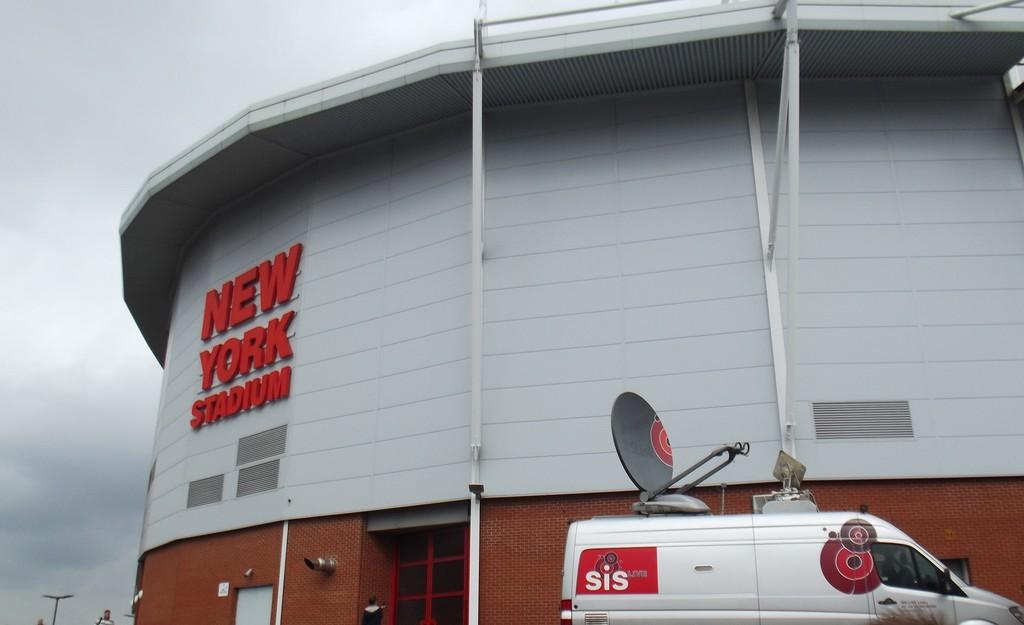<image>
Summarize the visual content of the image. a truck parked outside the new york stadium 